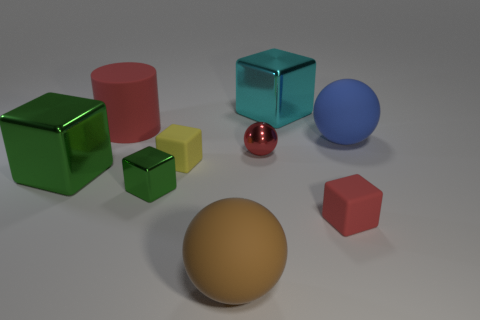Is the color of the tiny matte block right of the yellow matte object the same as the object that is on the left side of the rubber cylinder?
Provide a short and direct response. No. Are there any large green cubes made of the same material as the large cyan block?
Offer a terse response. Yes. What number of gray objects are either large rubber spheres or tiny shiny balls?
Give a very brief answer. 0. Are there more green metallic cubes behind the big blue thing than large purple cubes?
Provide a succinct answer. No. Is the size of the brown object the same as the blue thing?
Your answer should be compact. Yes. What color is the small cube that is the same material as the large green cube?
Provide a short and direct response. Green. There is a shiny thing that is the same color as the cylinder; what shape is it?
Keep it short and to the point. Sphere. Is the number of big blue spheres that are on the left side of the red block the same as the number of large brown things that are in front of the big cylinder?
Provide a short and direct response. No. What shape is the object in front of the tiny object on the right side of the cyan shiny object?
Your response must be concise. Sphere. What is the material of the other big object that is the same shape as the large green thing?
Your answer should be compact. Metal. 